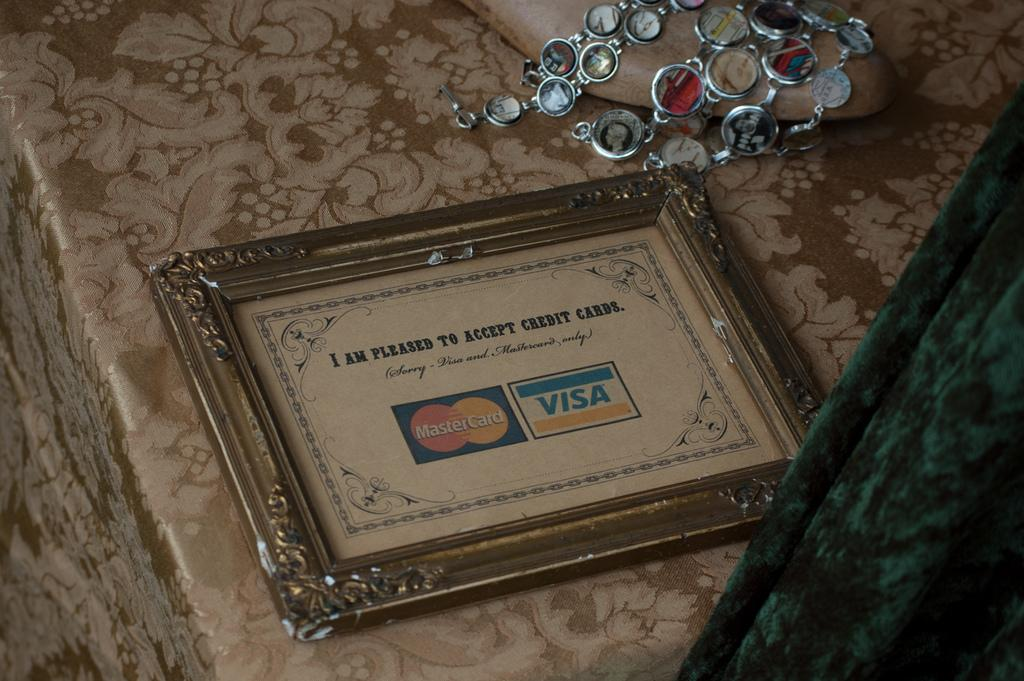<image>
Create a compact narrative representing the image presented. A frame with a Visa and MasterCard in it 